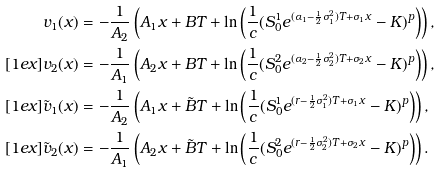Convert formula to latex. <formula><loc_0><loc_0><loc_500><loc_500>v _ { 1 } ( x ) & = - \frac { 1 } { A _ { 2 } } \left ( A _ { 1 } x + B T + \ln \left ( \frac { 1 } { c } ( S ^ { 1 } _ { 0 } e ^ { ( \alpha _ { 1 } - \frac { 1 } { 2 } \sigma _ { 1 } ^ { 2 } ) T + \sigma _ { 1 } x } - K ) ^ { p } \right ) \right ) , \\ [ 1 e x ] v _ { 2 } ( x ) & = - \frac { 1 } { A _ { 1 } } \left ( A _ { 2 } x + B T + \ln \left ( \frac { 1 } { c } ( S ^ { 2 } _ { 0 } e ^ { ( \alpha _ { 2 } - \frac { 1 } { 2 } \sigma _ { 2 } ^ { 2 } ) T + \sigma _ { 2 } x } - K ) ^ { p } \right ) \right ) , \\ [ 1 e x ] \tilde { v } _ { 1 } ( x ) & = - \frac { 1 } { A _ { 2 } } \left ( A _ { 1 } x + \tilde { B } T + \ln \left ( \frac { 1 } { c } ( S ^ { 1 } _ { 0 } e ^ { ( r - \frac { 1 } { 2 } \sigma _ { 1 } ^ { 2 } ) T + \sigma _ { 1 } x } - K ) ^ { p } \right ) \right ) , \\ [ 1 e x ] \tilde { v } _ { 2 } ( x ) & = - \frac { 1 } { A _ { 1 } } \left ( A _ { 2 } x + \tilde { B } T + \ln \left ( \frac { 1 } { c } ( S ^ { 2 } _ { 0 } e ^ { ( r - \frac { 1 } { 2 } \sigma _ { 2 } ^ { 2 } ) T + \sigma _ { 2 } x } - K ) ^ { p } \right ) \right ) .</formula> 